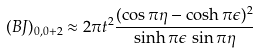<formula> <loc_0><loc_0><loc_500><loc_500>( B J ) _ { 0 , 0 + 2 } \approx 2 \pi t ^ { 2 } \frac { ( \cos \pi \eta - \cosh \pi \epsilon ) ^ { 2 } } { \sinh \pi \epsilon \, \sin \pi \eta }</formula> 